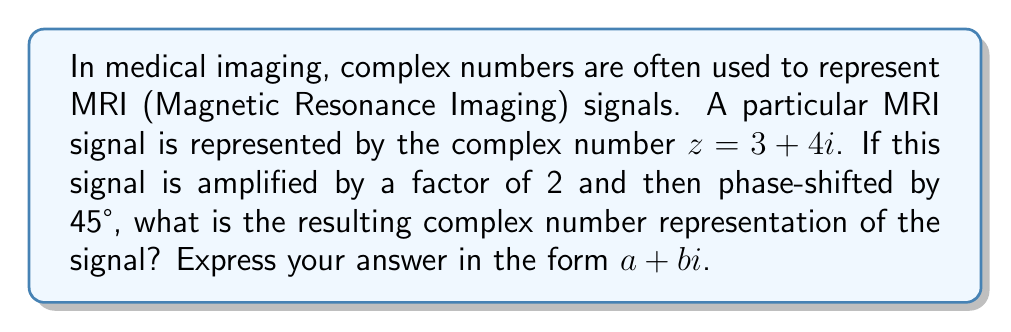Provide a solution to this math problem. To solve this problem, we'll follow these steps:

1. Amplification:
   The original signal $z = 3 + 4i$ is amplified by a factor of 2.
   $$z_1 = 2z = 2(3 + 4i) = 6 + 8i$$

2. Phase shift:
   A phase shift of 45° is equivalent to multiplying by $e^{i\theta}$, where $\theta = 45° = \frac{\pi}{4}$ radians.
   $$z_2 = z_1 \cdot e^{i\frac{\pi}{4}}$$

3. Euler's formula:
   $e^{i\frac{\pi}{4}} = \cos(\frac{\pi}{4}) + i\sin(\frac{\pi}{4}) = \frac{\sqrt{2}}{2} + i\frac{\sqrt{2}}{2}$

4. Multiplication:
   $$\begin{align*}
   z_2 &= (6 + 8i) \cdot (\frac{\sqrt{2}}{2} + i\frac{\sqrt{2}}{2}) \\
   &= 6\frac{\sqrt{2}}{2} + 6i\frac{\sqrt{2}}{2} + 8i\frac{\sqrt{2}}{2} - 8\frac{\sqrt{2}}{2} \\
   &= (6-8)\frac{\sqrt{2}}{2} + (6+8)i\frac{\sqrt{2}}{2} \\
   &= -2\frac{\sqrt{2}}{2} + 14i\frac{\sqrt{2}}{2}
   \end{align*}$$

5. Simplification:
   $$z_2 = -\sqrt{2} + 7\sqrt{2}i$$

This is the final complex number representation of the amplified and phase-shifted MRI signal.
Answer: $-\sqrt{2} + 7\sqrt{2}i$ 